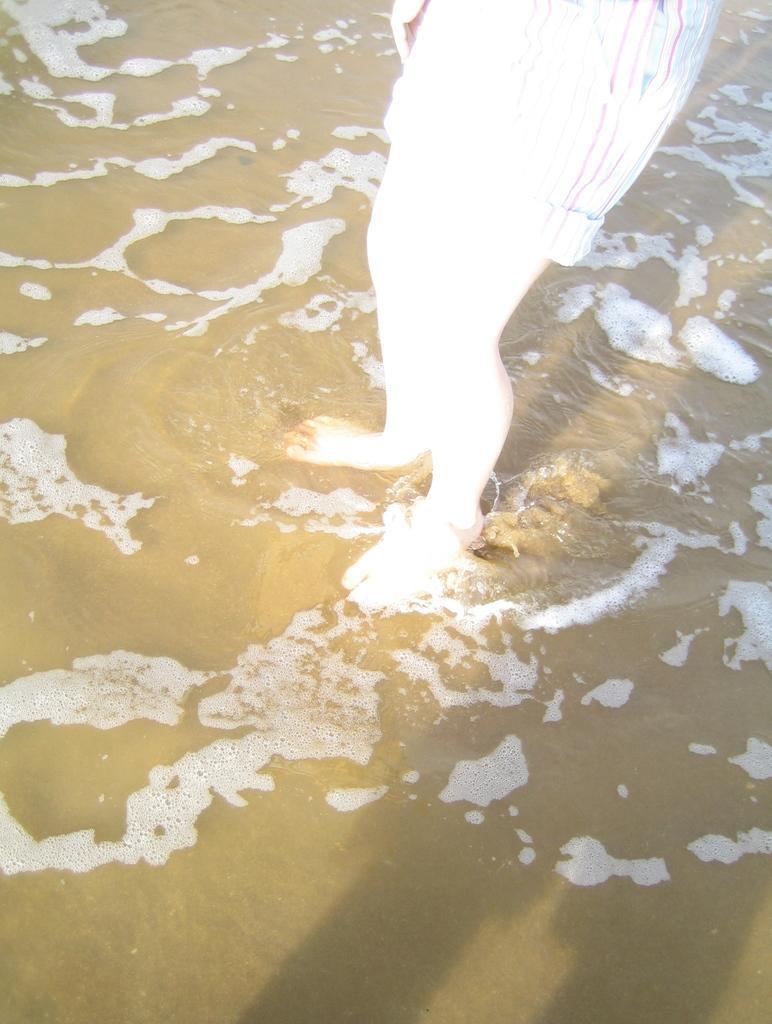How would you summarize this image in a sentence or two? In this image I can see the person wearing the dress and standing in the water. 